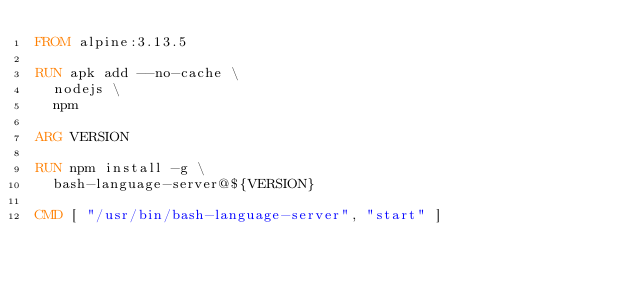Convert code to text. <code><loc_0><loc_0><loc_500><loc_500><_Dockerfile_>FROM alpine:3.13.5

RUN apk add --no-cache \
  nodejs \
  npm

ARG VERSION

RUN npm install -g \
  bash-language-server@${VERSION}

CMD [ "/usr/bin/bash-language-server", "start" ]
</code> 